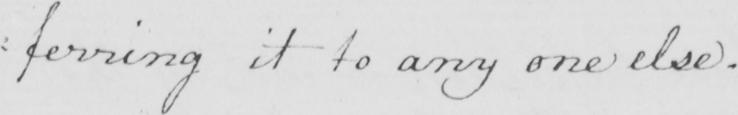What does this handwritten line say? : ferring it to any one else . 